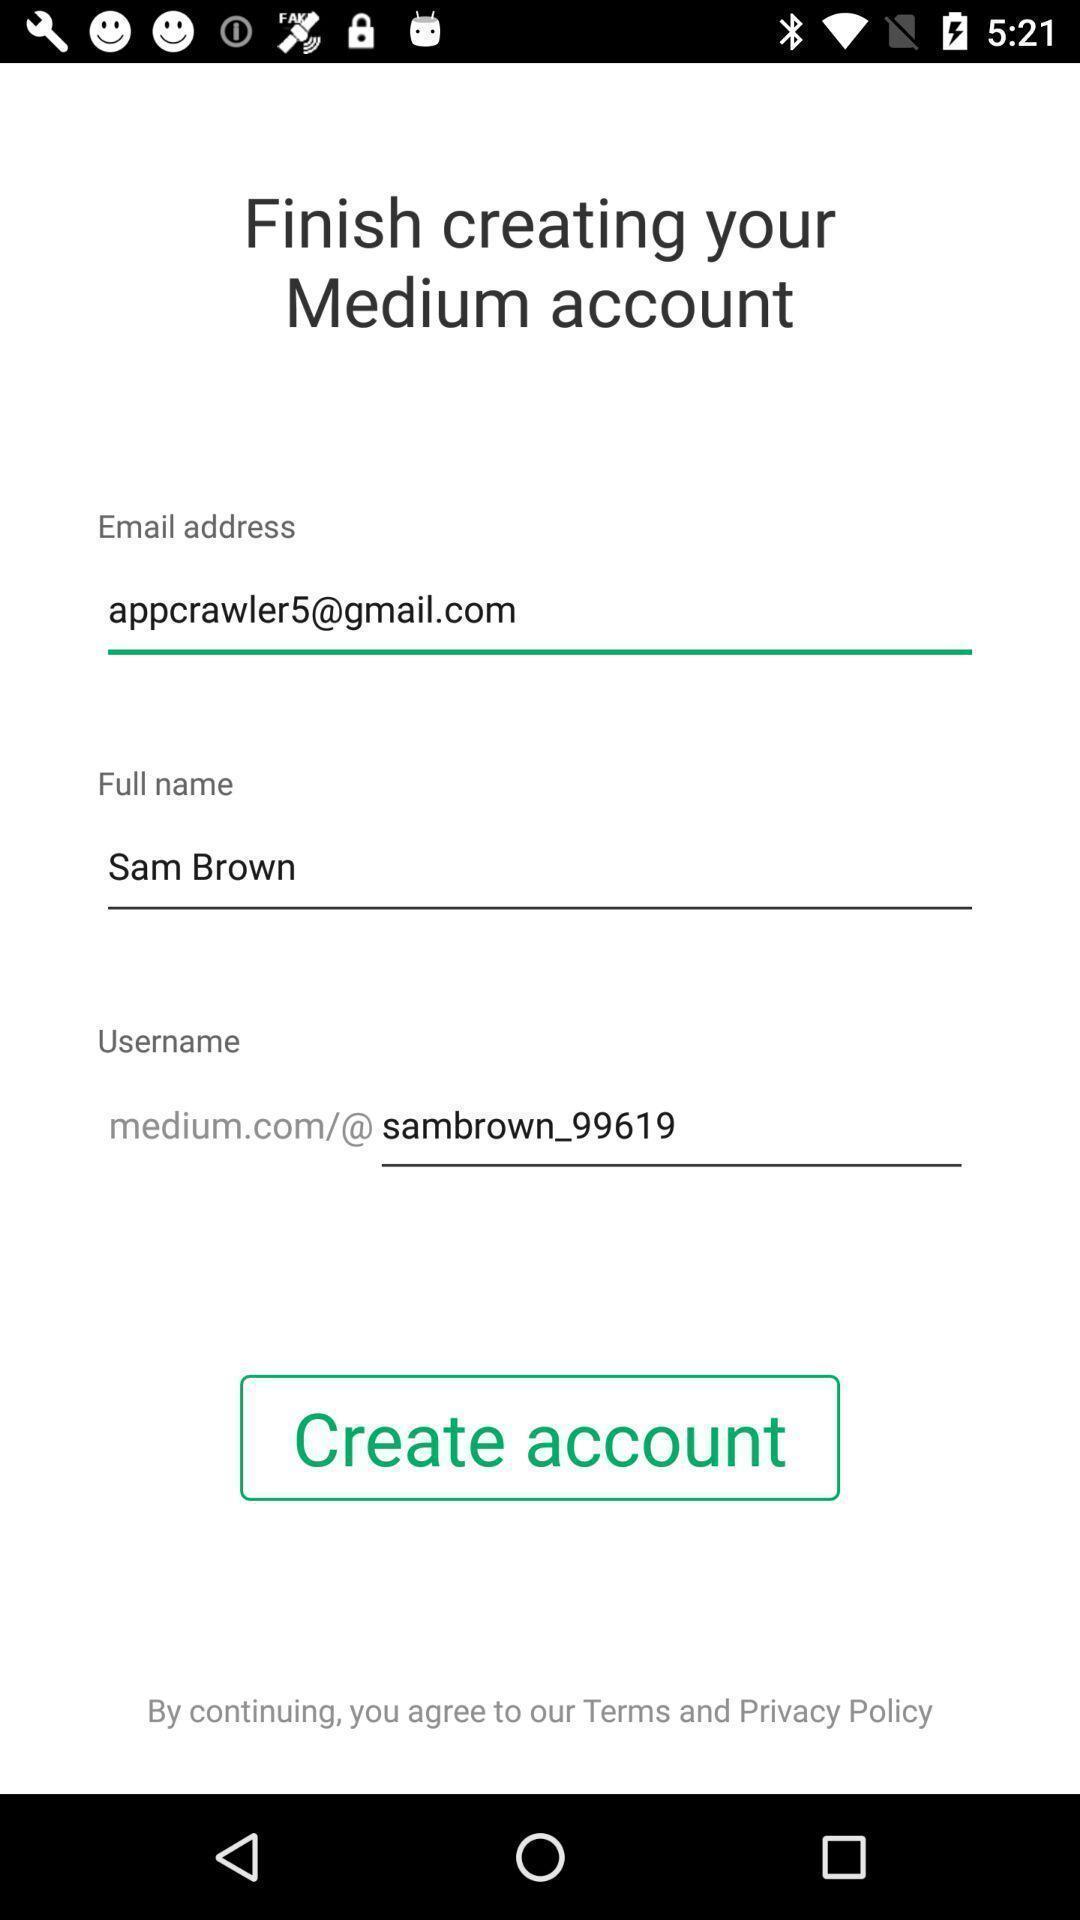Summarize the information in this screenshot. Page showing the input fields of publishing app. 